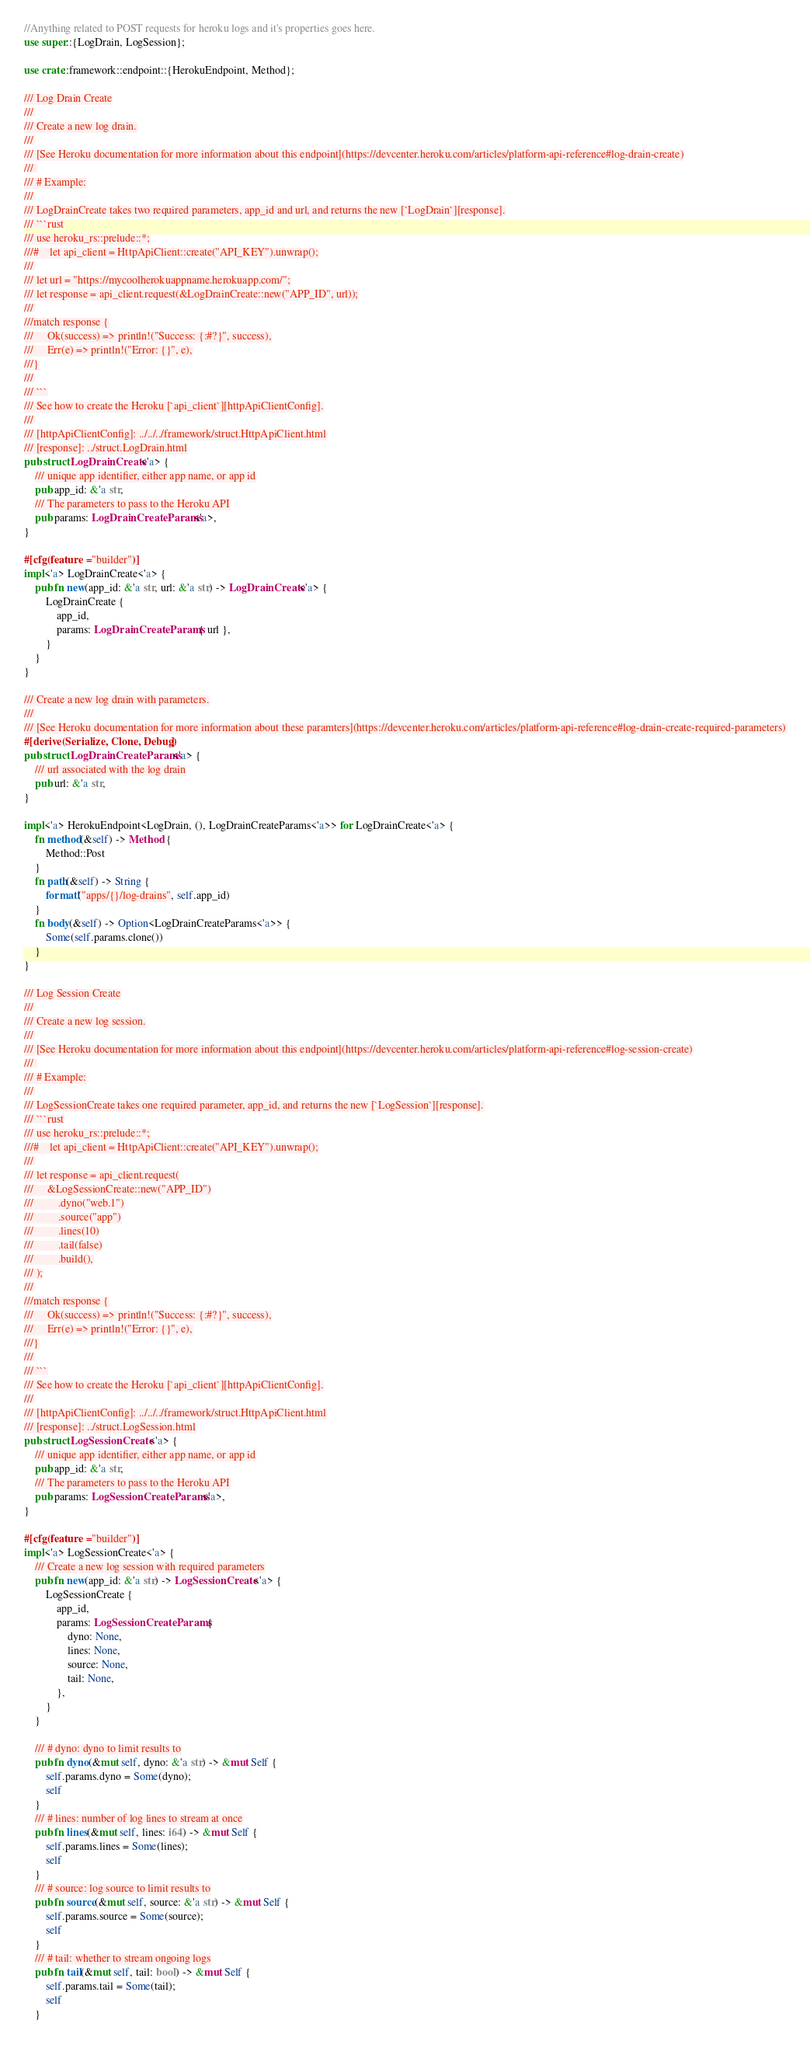<code> <loc_0><loc_0><loc_500><loc_500><_Rust_>//Anything related to POST requests for heroku logs and it's properties goes here.
use super::{LogDrain, LogSession};

use crate::framework::endpoint::{HerokuEndpoint, Method};

/// Log Drain Create
///
/// Create a new log drain.
///
/// [See Heroku documentation for more information about this endpoint](https://devcenter.heroku.com/articles/platform-api-reference#log-drain-create)
/// 
/// # Example:
///
/// LogDrainCreate takes two required parameters, app_id and url, and returns the new [`LogDrain`][response].
/// ```rust
/// use heroku_rs::prelude::*;
///#    let api_client = HttpApiClient::create("API_KEY").unwrap();
///
/// let url = "https://mycoolherokuappname.herokuapp.com/";
/// let response = api_client.request(&LogDrainCreate::new("APP_ID", url));
///
///match response {
///     Ok(success) => println!("Success: {:#?}", success),
///     Err(e) => println!("Error: {}", e),
///}
///
/// ```
/// See how to create the Heroku [`api_client`][httpApiClientConfig].
///
/// [httpApiClientConfig]: ../../../framework/struct.HttpApiClient.html
/// [response]: ../struct.LogDrain.html
pub struct LogDrainCreate<'a> {
    /// unique app identifier, either app name, or app id
    pub app_id: &'a str,
    /// The parameters to pass to the Heroku API
    pub params: LogDrainCreateParams<'a>,
}

#[cfg(feature = "builder")]
impl<'a> LogDrainCreate<'a> {
    pub fn new(app_id: &'a str, url: &'a str) -> LogDrainCreate<'a> {
        LogDrainCreate {
            app_id,
            params: LogDrainCreateParams { url },
        }
    }
}

/// Create a new log drain with parameters.
///
/// [See Heroku documentation for more information about these paramters](https://devcenter.heroku.com/articles/platform-api-reference#log-drain-create-required-parameters)
#[derive(Serialize, Clone, Debug)]
pub struct LogDrainCreateParams<'a> {
    /// url associated with the log drain
    pub url: &'a str,
}

impl<'a> HerokuEndpoint<LogDrain, (), LogDrainCreateParams<'a>> for LogDrainCreate<'a> {
    fn method(&self) -> Method {
        Method::Post
    }
    fn path(&self) -> String {
        format!("apps/{}/log-drains", self.app_id)
    }
    fn body(&self) -> Option<LogDrainCreateParams<'a>> {
        Some(self.params.clone())
    }
}

/// Log Session Create
///
/// Create a new log session.
///
/// [See Heroku documentation for more information about this endpoint](https://devcenter.heroku.com/articles/platform-api-reference#log-session-create)
/// 
/// # Example:
///
/// LogSessionCreate takes one required parameter, app_id, and returns the new [`LogSession`][response].
/// ```rust
/// use heroku_rs::prelude::*;
///#    let api_client = HttpApiClient::create("API_KEY").unwrap();
///
/// let response = api_client.request(
///     &LogSessionCreate::new("APP_ID")
///         .dyno("web.1")
///         .source("app")
///         .lines(10)
///         .tail(false)
///         .build(),
/// );
///
///match response {
///     Ok(success) => println!("Success: {:#?}", success),
///     Err(e) => println!("Error: {}", e),
///}
///
/// ```
/// See how to create the Heroku [`api_client`][httpApiClientConfig].
///
/// [httpApiClientConfig]: ../../../framework/struct.HttpApiClient.html
/// [response]: ../struct.LogSession.html
pub struct LogSessionCreate<'a> {
    /// unique app identifier, either app name, or app id
    pub app_id: &'a str,
    /// The parameters to pass to the Heroku API
    pub params: LogSessionCreateParams<'a>,
}

#[cfg(feature = "builder")]
impl<'a> LogSessionCreate<'a> {
    /// Create a new log session with required parameters
    pub fn new(app_id: &'a str) -> LogSessionCreate<'a> {
        LogSessionCreate {
            app_id,
            params: LogSessionCreateParams {
                dyno: None,
                lines: None,
                source: None,
                tail: None,
            },
        }
    }

    /// # dyno: dyno to limit results to
    pub fn dyno(&mut self, dyno: &'a str) -> &mut Self {
        self.params.dyno = Some(dyno);
        self
    }
    /// # lines: number of log lines to stream at once
    pub fn lines(&mut self, lines: i64) -> &mut Self {
        self.params.lines = Some(lines);
        self
    }
    /// # source: log source to limit results to
    pub fn source(&mut self, source: &'a str) -> &mut Self {
        self.params.source = Some(source);
        self
    }
    /// # tail: whether to stream ongoing logs
    pub fn tail(&mut self, tail: bool) -> &mut Self {
        self.params.tail = Some(tail);
        self
    }
</code> 